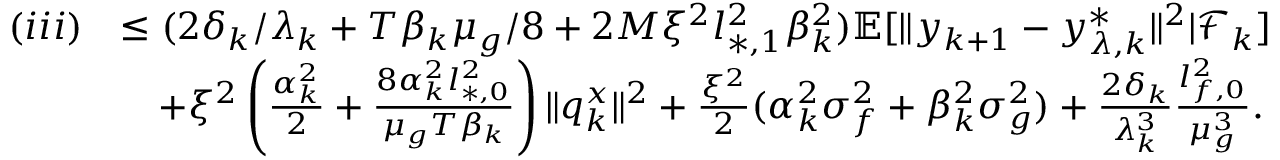Convert formula to latex. <formula><loc_0><loc_0><loc_500><loc_500>\begin{array} { r l } { ( i i i ) } & { \leq ( 2 \delta _ { k } / \lambda _ { k } + T \beta _ { k } \mu _ { g } / 8 + 2 M \xi ^ { 2 } l _ { * , 1 } ^ { 2 } \beta _ { k } ^ { 2 } ) \mathbb { E } [ \| y _ { k + 1 } - y _ { \lambda , k } ^ { * } \| ^ { 2 } | \mathcal { F } _ { k } ] } \\ & { \quad + \xi ^ { 2 } \left ( \frac { \alpha _ { k } ^ { 2 } } { 2 } + \frac { 8 \alpha _ { k } ^ { 2 } l _ { * , 0 } ^ { 2 } } { \mu _ { g } T \beta _ { k } } \right ) \| q _ { k } ^ { x } \| ^ { 2 } + \frac { \xi ^ { 2 } } { 2 } ( \alpha _ { k } ^ { 2 } \sigma _ { f } ^ { 2 } + \beta _ { k } ^ { 2 } \sigma _ { g } ^ { 2 } ) + \frac { 2 \delta _ { k } } { \lambda _ { k } ^ { 3 } } \frac { l _ { f , 0 } ^ { 2 } } { \mu _ { g } ^ { 3 } } . } \end{array}</formula> 